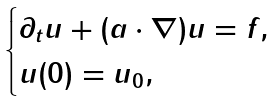<formula> <loc_0><loc_0><loc_500><loc_500>\begin{cases} \partial _ { t } u + ( a \cdot \nabla ) u = f , \\ u ( 0 ) = u _ { 0 } , \end{cases}</formula> 